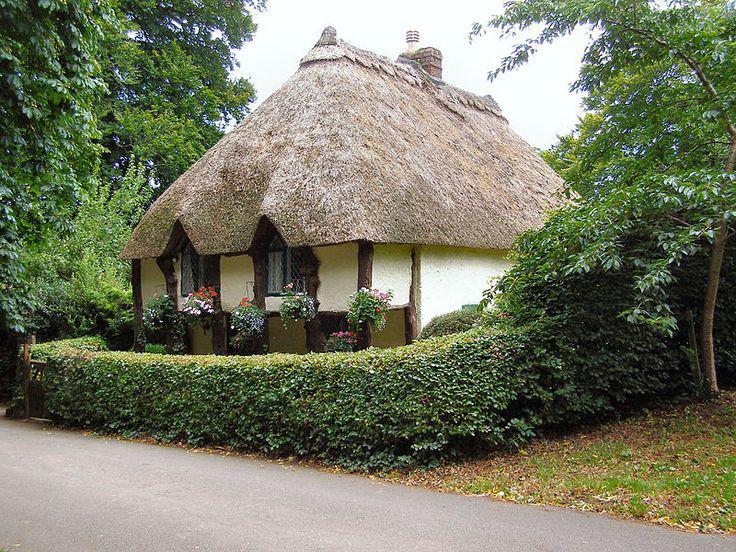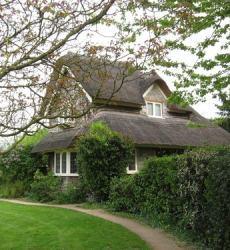The first image is the image on the left, the second image is the image on the right. Examine the images to the left and right. Is the description "The left image shows a house with a thick gray roof covering the front and sides, topped with a chimney and a scalloped border." accurate? Answer yes or no. Yes. 